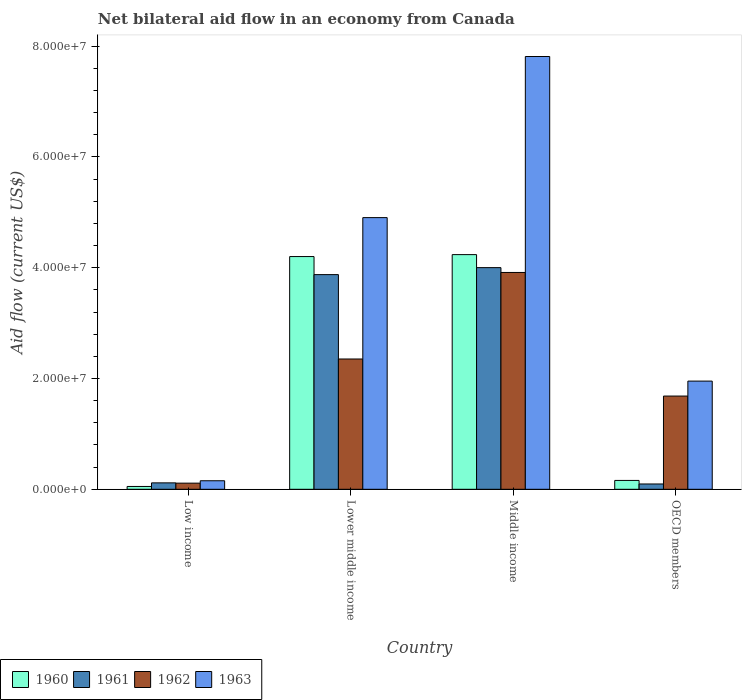How many different coloured bars are there?
Make the answer very short. 4. How many groups of bars are there?
Keep it short and to the point. 4. What is the label of the 2nd group of bars from the left?
Make the answer very short. Lower middle income. What is the net bilateral aid flow in 1960 in OECD members?
Make the answer very short. 1.60e+06. Across all countries, what is the maximum net bilateral aid flow in 1960?
Offer a terse response. 4.24e+07. Across all countries, what is the minimum net bilateral aid flow in 1963?
Provide a succinct answer. 1.54e+06. What is the total net bilateral aid flow in 1963 in the graph?
Give a very brief answer. 1.48e+08. What is the difference between the net bilateral aid flow in 1961 in Lower middle income and that in OECD members?
Offer a very short reply. 3.78e+07. What is the difference between the net bilateral aid flow in 1963 in Low income and the net bilateral aid flow in 1961 in Lower middle income?
Provide a succinct answer. -3.72e+07. What is the average net bilateral aid flow in 1962 per country?
Offer a very short reply. 2.02e+07. What is the difference between the net bilateral aid flow of/in 1963 and net bilateral aid flow of/in 1960 in Middle income?
Offer a terse response. 3.58e+07. What is the ratio of the net bilateral aid flow in 1963 in Low income to that in Middle income?
Make the answer very short. 0.02. What is the difference between the highest and the second highest net bilateral aid flow in 1963?
Your answer should be very brief. 5.86e+07. What is the difference between the highest and the lowest net bilateral aid flow in 1962?
Provide a short and direct response. 3.80e+07. In how many countries, is the net bilateral aid flow in 1962 greater than the average net bilateral aid flow in 1962 taken over all countries?
Your answer should be compact. 2. Is the sum of the net bilateral aid flow in 1960 in Middle income and OECD members greater than the maximum net bilateral aid flow in 1962 across all countries?
Offer a very short reply. Yes. Is it the case that in every country, the sum of the net bilateral aid flow in 1963 and net bilateral aid flow in 1960 is greater than the sum of net bilateral aid flow in 1962 and net bilateral aid flow in 1961?
Keep it short and to the point. No. What does the 1st bar from the left in OECD members represents?
Offer a terse response. 1960. What does the 1st bar from the right in Lower middle income represents?
Keep it short and to the point. 1963. Is it the case that in every country, the sum of the net bilateral aid flow in 1961 and net bilateral aid flow in 1963 is greater than the net bilateral aid flow in 1962?
Ensure brevity in your answer.  Yes. Are all the bars in the graph horizontal?
Give a very brief answer. No. Are the values on the major ticks of Y-axis written in scientific E-notation?
Your answer should be compact. Yes. Does the graph contain grids?
Make the answer very short. No. Where does the legend appear in the graph?
Offer a very short reply. Bottom left. How many legend labels are there?
Your answer should be very brief. 4. How are the legend labels stacked?
Your answer should be very brief. Horizontal. What is the title of the graph?
Your answer should be very brief. Net bilateral aid flow in an economy from Canada. What is the Aid flow (current US$) in 1960 in Low income?
Ensure brevity in your answer.  5.10e+05. What is the Aid flow (current US$) of 1961 in Low income?
Offer a terse response. 1.16e+06. What is the Aid flow (current US$) of 1962 in Low income?
Provide a succinct answer. 1.11e+06. What is the Aid flow (current US$) in 1963 in Low income?
Provide a succinct answer. 1.54e+06. What is the Aid flow (current US$) of 1960 in Lower middle income?
Provide a short and direct response. 4.20e+07. What is the Aid flow (current US$) in 1961 in Lower middle income?
Provide a succinct answer. 3.88e+07. What is the Aid flow (current US$) in 1962 in Lower middle income?
Your answer should be compact. 2.35e+07. What is the Aid flow (current US$) of 1963 in Lower middle income?
Your answer should be compact. 4.90e+07. What is the Aid flow (current US$) of 1960 in Middle income?
Your response must be concise. 4.24e+07. What is the Aid flow (current US$) in 1961 in Middle income?
Keep it short and to the point. 4.00e+07. What is the Aid flow (current US$) in 1962 in Middle income?
Offer a very short reply. 3.91e+07. What is the Aid flow (current US$) of 1963 in Middle income?
Your response must be concise. 7.81e+07. What is the Aid flow (current US$) in 1960 in OECD members?
Your answer should be very brief. 1.60e+06. What is the Aid flow (current US$) in 1961 in OECD members?
Provide a short and direct response. 9.60e+05. What is the Aid flow (current US$) of 1962 in OECD members?
Provide a succinct answer. 1.68e+07. What is the Aid flow (current US$) of 1963 in OECD members?
Provide a short and direct response. 1.95e+07. Across all countries, what is the maximum Aid flow (current US$) in 1960?
Offer a very short reply. 4.24e+07. Across all countries, what is the maximum Aid flow (current US$) of 1961?
Offer a very short reply. 4.00e+07. Across all countries, what is the maximum Aid flow (current US$) of 1962?
Keep it short and to the point. 3.91e+07. Across all countries, what is the maximum Aid flow (current US$) of 1963?
Your response must be concise. 7.81e+07. Across all countries, what is the minimum Aid flow (current US$) in 1960?
Keep it short and to the point. 5.10e+05. Across all countries, what is the minimum Aid flow (current US$) of 1961?
Keep it short and to the point. 9.60e+05. Across all countries, what is the minimum Aid flow (current US$) in 1962?
Provide a succinct answer. 1.11e+06. Across all countries, what is the minimum Aid flow (current US$) of 1963?
Your answer should be compact. 1.54e+06. What is the total Aid flow (current US$) of 1960 in the graph?
Provide a short and direct response. 8.65e+07. What is the total Aid flow (current US$) of 1961 in the graph?
Offer a terse response. 8.09e+07. What is the total Aid flow (current US$) of 1962 in the graph?
Give a very brief answer. 8.06e+07. What is the total Aid flow (current US$) of 1963 in the graph?
Offer a terse response. 1.48e+08. What is the difference between the Aid flow (current US$) in 1960 in Low income and that in Lower middle income?
Give a very brief answer. -4.15e+07. What is the difference between the Aid flow (current US$) in 1961 in Low income and that in Lower middle income?
Make the answer very short. -3.76e+07. What is the difference between the Aid flow (current US$) of 1962 in Low income and that in Lower middle income?
Offer a very short reply. -2.24e+07. What is the difference between the Aid flow (current US$) in 1963 in Low income and that in Lower middle income?
Your answer should be compact. -4.75e+07. What is the difference between the Aid flow (current US$) of 1960 in Low income and that in Middle income?
Offer a terse response. -4.18e+07. What is the difference between the Aid flow (current US$) in 1961 in Low income and that in Middle income?
Provide a succinct answer. -3.88e+07. What is the difference between the Aid flow (current US$) in 1962 in Low income and that in Middle income?
Your response must be concise. -3.80e+07. What is the difference between the Aid flow (current US$) in 1963 in Low income and that in Middle income?
Keep it short and to the point. -7.66e+07. What is the difference between the Aid flow (current US$) in 1960 in Low income and that in OECD members?
Your answer should be very brief. -1.09e+06. What is the difference between the Aid flow (current US$) of 1962 in Low income and that in OECD members?
Make the answer very short. -1.57e+07. What is the difference between the Aid flow (current US$) of 1963 in Low income and that in OECD members?
Make the answer very short. -1.80e+07. What is the difference between the Aid flow (current US$) of 1960 in Lower middle income and that in Middle income?
Ensure brevity in your answer.  -3.50e+05. What is the difference between the Aid flow (current US$) in 1961 in Lower middle income and that in Middle income?
Keep it short and to the point. -1.26e+06. What is the difference between the Aid flow (current US$) of 1962 in Lower middle income and that in Middle income?
Give a very brief answer. -1.56e+07. What is the difference between the Aid flow (current US$) in 1963 in Lower middle income and that in Middle income?
Give a very brief answer. -2.91e+07. What is the difference between the Aid flow (current US$) of 1960 in Lower middle income and that in OECD members?
Give a very brief answer. 4.04e+07. What is the difference between the Aid flow (current US$) in 1961 in Lower middle income and that in OECD members?
Your answer should be very brief. 3.78e+07. What is the difference between the Aid flow (current US$) in 1962 in Lower middle income and that in OECD members?
Ensure brevity in your answer.  6.69e+06. What is the difference between the Aid flow (current US$) in 1963 in Lower middle income and that in OECD members?
Make the answer very short. 2.95e+07. What is the difference between the Aid flow (current US$) of 1960 in Middle income and that in OECD members?
Offer a terse response. 4.08e+07. What is the difference between the Aid flow (current US$) in 1961 in Middle income and that in OECD members?
Your answer should be compact. 3.90e+07. What is the difference between the Aid flow (current US$) in 1962 in Middle income and that in OECD members?
Offer a very short reply. 2.23e+07. What is the difference between the Aid flow (current US$) in 1963 in Middle income and that in OECD members?
Provide a succinct answer. 5.86e+07. What is the difference between the Aid flow (current US$) in 1960 in Low income and the Aid flow (current US$) in 1961 in Lower middle income?
Keep it short and to the point. -3.82e+07. What is the difference between the Aid flow (current US$) of 1960 in Low income and the Aid flow (current US$) of 1962 in Lower middle income?
Your answer should be very brief. -2.30e+07. What is the difference between the Aid flow (current US$) in 1960 in Low income and the Aid flow (current US$) in 1963 in Lower middle income?
Ensure brevity in your answer.  -4.85e+07. What is the difference between the Aid flow (current US$) in 1961 in Low income and the Aid flow (current US$) in 1962 in Lower middle income?
Provide a short and direct response. -2.24e+07. What is the difference between the Aid flow (current US$) in 1961 in Low income and the Aid flow (current US$) in 1963 in Lower middle income?
Provide a succinct answer. -4.79e+07. What is the difference between the Aid flow (current US$) of 1962 in Low income and the Aid flow (current US$) of 1963 in Lower middle income?
Your response must be concise. -4.79e+07. What is the difference between the Aid flow (current US$) in 1960 in Low income and the Aid flow (current US$) in 1961 in Middle income?
Offer a terse response. -3.95e+07. What is the difference between the Aid flow (current US$) in 1960 in Low income and the Aid flow (current US$) in 1962 in Middle income?
Your answer should be very brief. -3.86e+07. What is the difference between the Aid flow (current US$) in 1960 in Low income and the Aid flow (current US$) in 1963 in Middle income?
Give a very brief answer. -7.76e+07. What is the difference between the Aid flow (current US$) in 1961 in Low income and the Aid flow (current US$) in 1962 in Middle income?
Your answer should be compact. -3.80e+07. What is the difference between the Aid flow (current US$) in 1961 in Low income and the Aid flow (current US$) in 1963 in Middle income?
Keep it short and to the point. -7.70e+07. What is the difference between the Aid flow (current US$) of 1962 in Low income and the Aid flow (current US$) of 1963 in Middle income?
Keep it short and to the point. -7.70e+07. What is the difference between the Aid flow (current US$) in 1960 in Low income and the Aid flow (current US$) in 1961 in OECD members?
Make the answer very short. -4.50e+05. What is the difference between the Aid flow (current US$) of 1960 in Low income and the Aid flow (current US$) of 1962 in OECD members?
Your response must be concise. -1.63e+07. What is the difference between the Aid flow (current US$) in 1960 in Low income and the Aid flow (current US$) in 1963 in OECD members?
Your response must be concise. -1.90e+07. What is the difference between the Aid flow (current US$) of 1961 in Low income and the Aid flow (current US$) of 1962 in OECD members?
Make the answer very short. -1.57e+07. What is the difference between the Aid flow (current US$) of 1961 in Low income and the Aid flow (current US$) of 1963 in OECD members?
Ensure brevity in your answer.  -1.84e+07. What is the difference between the Aid flow (current US$) of 1962 in Low income and the Aid flow (current US$) of 1963 in OECD members?
Your answer should be compact. -1.84e+07. What is the difference between the Aid flow (current US$) of 1960 in Lower middle income and the Aid flow (current US$) of 1961 in Middle income?
Make the answer very short. 2.00e+06. What is the difference between the Aid flow (current US$) of 1960 in Lower middle income and the Aid flow (current US$) of 1962 in Middle income?
Ensure brevity in your answer.  2.87e+06. What is the difference between the Aid flow (current US$) in 1960 in Lower middle income and the Aid flow (current US$) in 1963 in Middle income?
Offer a terse response. -3.61e+07. What is the difference between the Aid flow (current US$) in 1961 in Lower middle income and the Aid flow (current US$) in 1962 in Middle income?
Your answer should be very brief. -3.90e+05. What is the difference between the Aid flow (current US$) in 1961 in Lower middle income and the Aid flow (current US$) in 1963 in Middle income?
Provide a succinct answer. -3.94e+07. What is the difference between the Aid flow (current US$) in 1962 in Lower middle income and the Aid flow (current US$) in 1963 in Middle income?
Offer a very short reply. -5.46e+07. What is the difference between the Aid flow (current US$) in 1960 in Lower middle income and the Aid flow (current US$) in 1961 in OECD members?
Your answer should be very brief. 4.10e+07. What is the difference between the Aid flow (current US$) of 1960 in Lower middle income and the Aid flow (current US$) of 1962 in OECD members?
Offer a terse response. 2.52e+07. What is the difference between the Aid flow (current US$) of 1960 in Lower middle income and the Aid flow (current US$) of 1963 in OECD members?
Offer a terse response. 2.25e+07. What is the difference between the Aid flow (current US$) of 1961 in Lower middle income and the Aid flow (current US$) of 1962 in OECD members?
Ensure brevity in your answer.  2.19e+07. What is the difference between the Aid flow (current US$) in 1961 in Lower middle income and the Aid flow (current US$) in 1963 in OECD members?
Offer a very short reply. 1.92e+07. What is the difference between the Aid flow (current US$) of 1962 in Lower middle income and the Aid flow (current US$) of 1963 in OECD members?
Keep it short and to the point. 3.99e+06. What is the difference between the Aid flow (current US$) in 1960 in Middle income and the Aid flow (current US$) in 1961 in OECD members?
Offer a terse response. 4.14e+07. What is the difference between the Aid flow (current US$) of 1960 in Middle income and the Aid flow (current US$) of 1962 in OECD members?
Provide a succinct answer. 2.55e+07. What is the difference between the Aid flow (current US$) in 1960 in Middle income and the Aid flow (current US$) in 1963 in OECD members?
Keep it short and to the point. 2.28e+07. What is the difference between the Aid flow (current US$) in 1961 in Middle income and the Aid flow (current US$) in 1962 in OECD members?
Make the answer very short. 2.32e+07. What is the difference between the Aid flow (current US$) in 1961 in Middle income and the Aid flow (current US$) in 1963 in OECD members?
Give a very brief answer. 2.05e+07. What is the difference between the Aid flow (current US$) of 1962 in Middle income and the Aid flow (current US$) of 1963 in OECD members?
Give a very brief answer. 1.96e+07. What is the average Aid flow (current US$) of 1960 per country?
Your response must be concise. 2.16e+07. What is the average Aid flow (current US$) of 1961 per country?
Your answer should be compact. 2.02e+07. What is the average Aid flow (current US$) of 1962 per country?
Give a very brief answer. 2.02e+07. What is the average Aid flow (current US$) of 1963 per country?
Ensure brevity in your answer.  3.71e+07. What is the difference between the Aid flow (current US$) in 1960 and Aid flow (current US$) in 1961 in Low income?
Keep it short and to the point. -6.50e+05. What is the difference between the Aid flow (current US$) in 1960 and Aid flow (current US$) in 1962 in Low income?
Make the answer very short. -6.00e+05. What is the difference between the Aid flow (current US$) in 1960 and Aid flow (current US$) in 1963 in Low income?
Offer a very short reply. -1.03e+06. What is the difference between the Aid flow (current US$) of 1961 and Aid flow (current US$) of 1963 in Low income?
Your answer should be compact. -3.80e+05. What is the difference between the Aid flow (current US$) of 1962 and Aid flow (current US$) of 1963 in Low income?
Offer a very short reply. -4.30e+05. What is the difference between the Aid flow (current US$) in 1960 and Aid flow (current US$) in 1961 in Lower middle income?
Offer a terse response. 3.26e+06. What is the difference between the Aid flow (current US$) in 1960 and Aid flow (current US$) in 1962 in Lower middle income?
Offer a very short reply. 1.85e+07. What is the difference between the Aid flow (current US$) in 1960 and Aid flow (current US$) in 1963 in Lower middle income?
Ensure brevity in your answer.  -7.03e+06. What is the difference between the Aid flow (current US$) of 1961 and Aid flow (current US$) of 1962 in Lower middle income?
Offer a very short reply. 1.52e+07. What is the difference between the Aid flow (current US$) in 1961 and Aid flow (current US$) in 1963 in Lower middle income?
Your response must be concise. -1.03e+07. What is the difference between the Aid flow (current US$) in 1962 and Aid flow (current US$) in 1963 in Lower middle income?
Make the answer very short. -2.55e+07. What is the difference between the Aid flow (current US$) of 1960 and Aid flow (current US$) of 1961 in Middle income?
Make the answer very short. 2.35e+06. What is the difference between the Aid flow (current US$) in 1960 and Aid flow (current US$) in 1962 in Middle income?
Provide a succinct answer. 3.22e+06. What is the difference between the Aid flow (current US$) of 1960 and Aid flow (current US$) of 1963 in Middle income?
Your answer should be very brief. -3.58e+07. What is the difference between the Aid flow (current US$) in 1961 and Aid flow (current US$) in 1962 in Middle income?
Offer a very short reply. 8.70e+05. What is the difference between the Aid flow (current US$) of 1961 and Aid flow (current US$) of 1963 in Middle income?
Your response must be concise. -3.81e+07. What is the difference between the Aid flow (current US$) in 1962 and Aid flow (current US$) in 1963 in Middle income?
Make the answer very short. -3.90e+07. What is the difference between the Aid flow (current US$) of 1960 and Aid flow (current US$) of 1961 in OECD members?
Offer a terse response. 6.40e+05. What is the difference between the Aid flow (current US$) in 1960 and Aid flow (current US$) in 1962 in OECD members?
Keep it short and to the point. -1.52e+07. What is the difference between the Aid flow (current US$) in 1960 and Aid flow (current US$) in 1963 in OECD members?
Your answer should be compact. -1.79e+07. What is the difference between the Aid flow (current US$) of 1961 and Aid flow (current US$) of 1962 in OECD members?
Keep it short and to the point. -1.59e+07. What is the difference between the Aid flow (current US$) in 1961 and Aid flow (current US$) in 1963 in OECD members?
Provide a succinct answer. -1.86e+07. What is the difference between the Aid flow (current US$) of 1962 and Aid flow (current US$) of 1963 in OECD members?
Offer a terse response. -2.70e+06. What is the ratio of the Aid flow (current US$) in 1960 in Low income to that in Lower middle income?
Give a very brief answer. 0.01. What is the ratio of the Aid flow (current US$) in 1961 in Low income to that in Lower middle income?
Your answer should be compact. 0.03. What is the ratio of the Aid flow (current US$) of 1962 in Low income to that in Lower middle income?
Make the answer very short. 0.05. What is the ratio of the Aid flow (current US$) in 1963 in Low income to that in Lower middle income?
Your response must be concise. 0.03. What is the ratio of the Aid flow (current US$) in 1960 in Low income to that in Middle income?
Offer a terse response. 0.01. What is the ratio of the Aid flow (current US$) in 1961 in Low income to that in Middle income?
Give a very brief answer. 0.03. What is the ratio of the Aid flow (current US$) in 1962 in Low income to that in Middle income?
Provide a succinct answer. 0.03. What is the ratio of the Aid flow (current US$) in 1963 in Low income to that in Middle income?
Give a very brief answer. 0.02. What is the ratio of the Aid flow (current US$) of 1960 in Low income to that in OECD members?
Provide a succinct answer. 0.32. What is the ratio of the Aid flow (current US$) of 1961 in Low income to that in OECD members?
Give a very brief answer. 1.21. What is the ratio of the Aid flow (current US$) of 1962 in Low income to that in OECD members?
Make the answer very short. 0.07. What is the ratio of the Aid flow (current US$) of 1963 in Low income to that in OECD members?
Give a very brief answer. 0.08. What is the ratio of the Aid flow (current US$) in 1960 in Lower middle income to that in Middle income?
Your answer should be very brief. 0.99. What is the ratio of the Aid flow (current US$) in 1961 in Lower middle income to that in Middle income?
Provide a short and direct response. 0.97. What is the ratio of the Aid flow (current US$) of 1962 in Lower middle income to that in Middle income?
Provide a succinct answer. 0.6. What is the ratio of the Aid flow (current US$) in 1963 in Lower middle income to that in Middle income?
Make the answer very short. 0.63. What is the ratio of the Aid flow (current US$) in 1960 in Lower middle income to that in OECD members?
Provide a short and direct response. 26.26. What is the ratio of the Aid flow (current US$) in 1961 in Lower middle income to that in OECD members?
Your answer should be very brief. 40.36. What is the ratio of the Aid flow (current US$) in 1962 in Lower middle income to that in OECD members?
Offer a very short reply. 1.4. What is the ratio of the Aid flow (current US$) in 1963 in Lower middle income to that in OECD members?
Provide a short and direct response. 2.51. What is the ratio of the Aid flow (current US$) of 1960 in Middle income to that in OECD members?
Your answer should be compact. 26.48. What is the ratio of the Aid flow (current US$) of 1961 in Middle income to that in OECD members?
Provide a succinct answer. 41.68. What is the ratio of the Aid flow (current US$) of 1962 in Middle income to that in OECD members?
Ensure brevity in your answer.  2.33. What is the difference between the highest and the second highest Aid flow (current US$) in 1961?
Offer a terse response. 1.26e+06. What is the difference between the highest and the second highest Aid flow (current US$) of 1962?
Ensure brevity in your answer.  1.56e+07. What is the difference between the highest and the second highest Aid flow (current US$) of 1963?
Offer a terse response. 2.91e+07. What is the difference between the highest and the lowest Aid flow (current US$) of 1960?
Make the answer very short. 4.18e+07. What is the difference between the highest and the lowest Aid flow (current US$) of 1961?
Keep it short and to the point. 3.90e+07. What is the difference between the highest and the lowest Aid flow (current US$) in 1962?
Offer a terse response. 3.80e+07. What is the difference between the highest and the lowest Aid flow (current US$) in 1963?
Give a very brief answer. 7.66e+07. 